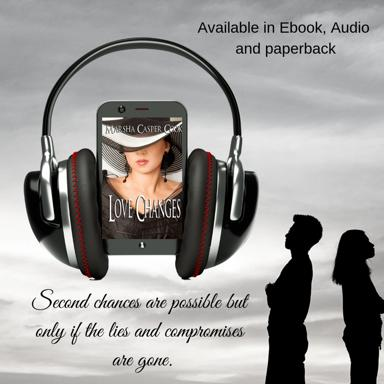What message might the shadowy figures convey in relation to the theme of the book? The silhouettes stand apart, which could symbolize a distance or disconnect that needs to be bridged. This visual element might suggest that to achieve second chances as referenced by the book, there must first be a recognition and traversal of the space that separates individuals. 